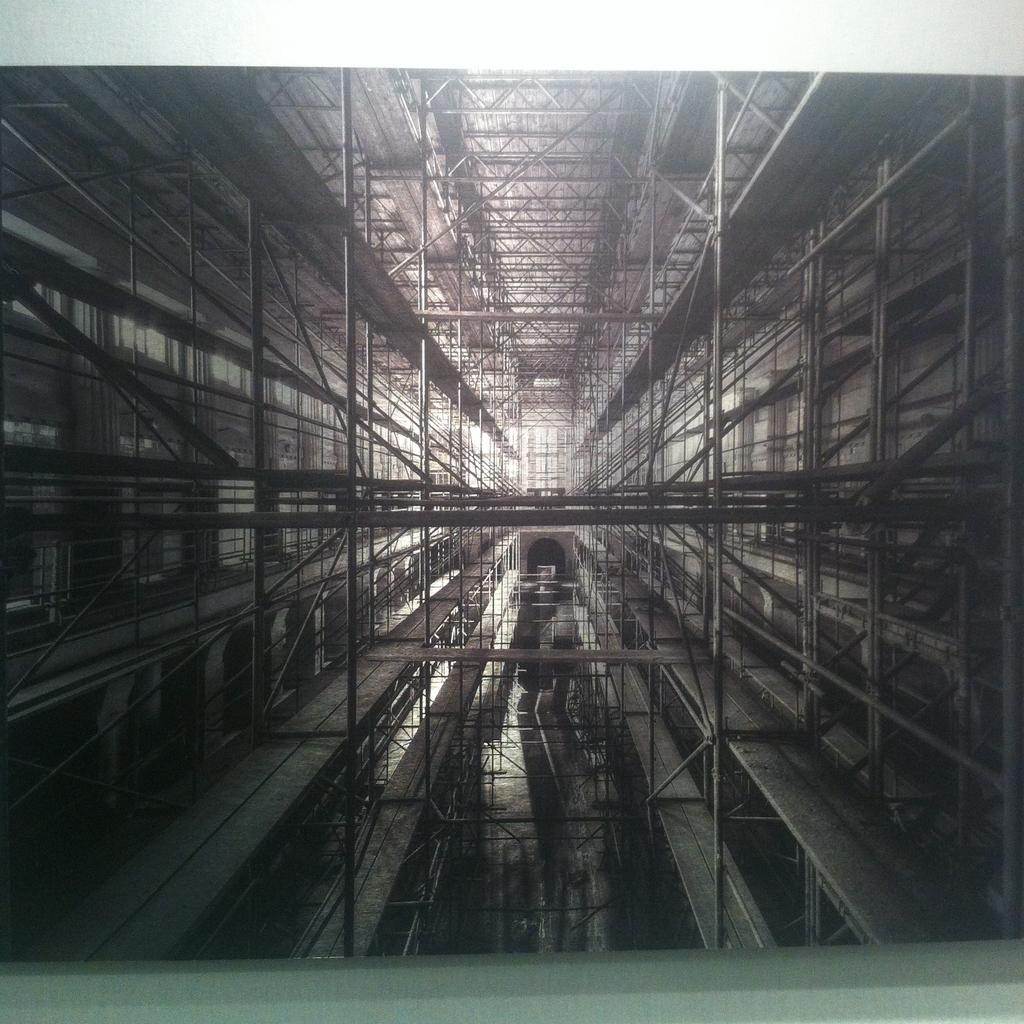What is the main structure in the foreground of the image? There is a metal rod structure in the foreground of the image. What material is used for the planks on both sides of the metal rod structure? The planks on both sides of the metal rod structure are made of wood. What is present at the top of the structure? There is a roof at the top of the structure. What type of industry is depicted in the image? There is no specific industry depicted in the image; it shows a metal rod structure with wooden planks and a roof. How many crates are visible in the image? There are no crates present in the image. 